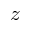Convert formula to latex. <formula><loc_0><loc_0><loc_500><loc_500>z</formula> 